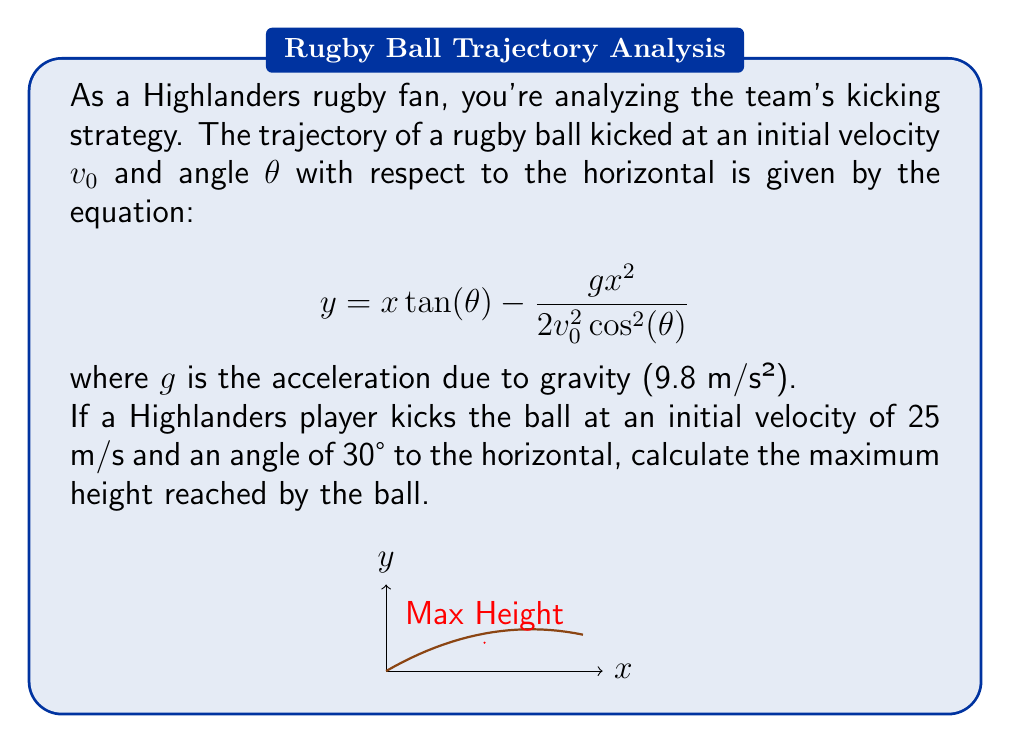Solve this math problem. Let's approach this step-by-step:

1) The maximum height is reached when $\frac{dy}{dx} = 0$. Let's find this point:

   $$\frac{dy}{dx} = \tan(\theta) - \frac{gx}{v_0^2\cos^2(\theta)}$$

2) Set this equal to 0 and solve for x:

   $$\tan(\theta) - \frac{gx}{v_0^2\cos^2(\theta)} = 0$$
   $$\frac{gx}{v_0^2\cos^2(\theta)} = \tan(\theta)$$
   $$x = \frac{v_0^2\sin(\theta)\cos(\theta)}{g}$$

3) Now, let's plug in our values:
   $v_0 = 25$ m/s
   $\theta = 30°$
   $g = 9.8$ m/s²

   $$x = \frac{25^2 \sin(30°)\cos(30°)}{9.8} \approx 27.23\text{ m}$$

4) To find the maximum height, we plug this x-value back into our original equation:

   $$y = x \tan(30°) - \frac{9.8x^2}{2(25^2)\cos^2(30°)}$$

5) Simplifying:

   $$y = 27.23 \cdot \frac{1}{\sqrt{3}} - \frac{9.8 \cdot 27.23^2}{2 \cdot 25^2 \cdot \frac{3}{4}}$$
   $$y \approx 15.72 - 7.86 = 7.86\text{ m}$$

Therefore, the maximum height reached by the ball is approximately 7.86 meters.
Answer: 7.86 m 